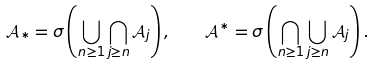<formula> <loc_0><loc_0><loc_500><loc_500>\mathcal { A } _ { * } = \sigma \left ( \bigcup _ { n \geq 1 } \bigcap _ { j \geq n } \mathcal { A } _ { j } \right ) , \quad \mathcal { A } ^ { * } = \sigma \left ( \bigcap _ { n \geq 1 } \bigcup _ { j \geq n } \mathcal { A } _ { j } \right ) .</formula> 